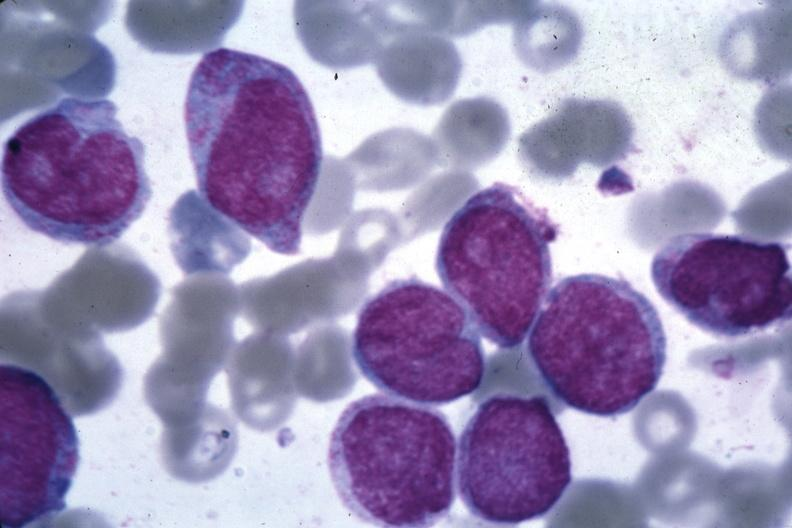s ovary present?
Answer the question using a single word or phrase. No 